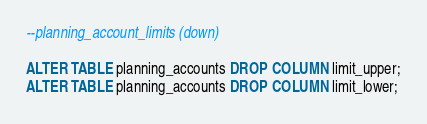<code> <loc_0><loc_0><loc_500><loc_500><_SQL_>--planning_account_limits (down)

ALTER TABLE planning_accounts DROP COLUMN limit_upper;
ALTER TABLE planning_accounts DROP COLUMN limit_lower;
</code> 